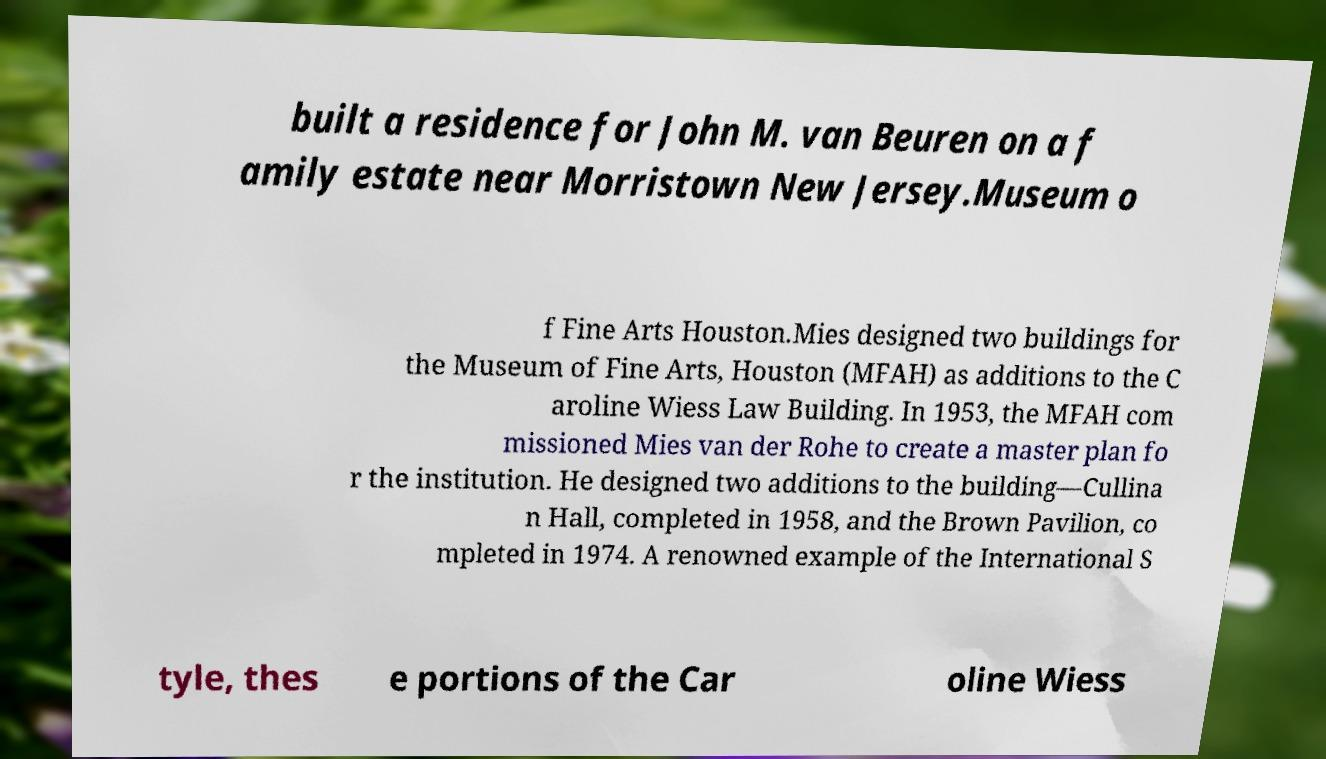Can you read and provide the text displayed in the image?This photo seems to have some interesting text. Can you extract and type it out for me? built a residence for John M. van Beuren on a f amily estate near Morristown New Jersey.Museum o f Fine Arts Houston.Mies designed two buildings for the Museum of Fine Arts, Houston (MFAH) as additions to the C aroline Wiess Law Building. In 1953, the MFAH com missioned Mies van der Rohe to create a master plan fo r the institution. He designed two additions to the building—Cullina n Hall, completed in 1958, and the Brown Pavilion, co mpleted in 1974. A renowned example of the International S tyle, thes e portions of the Car oline Wiess 